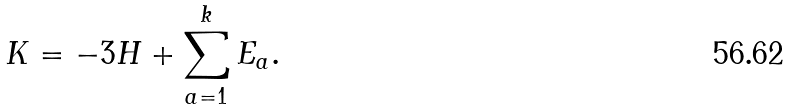Convert formula to latex. <formula><loc_0><loc_0><loc_500><loc_500>K = - 3 H + \sum _ { a = 1 } ^ { k } E _ { a } .</formula> 